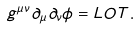Convert formula to latex. <formula><loc_0><loc_0><loc_500><loc_500>g ^ { \mu \nu } \partial _ { \mu } \partial _ { \nu } \phi = L O T .</formula> 